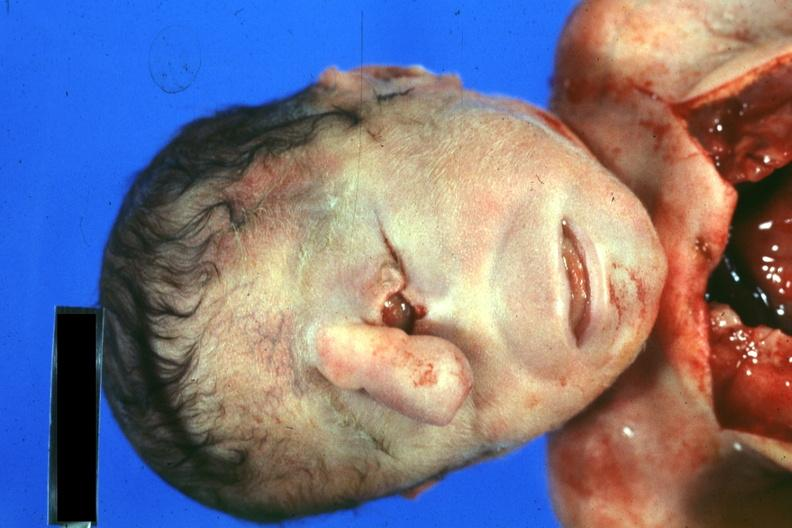s face present?
Answer the question using a single word or phrase. Yes 